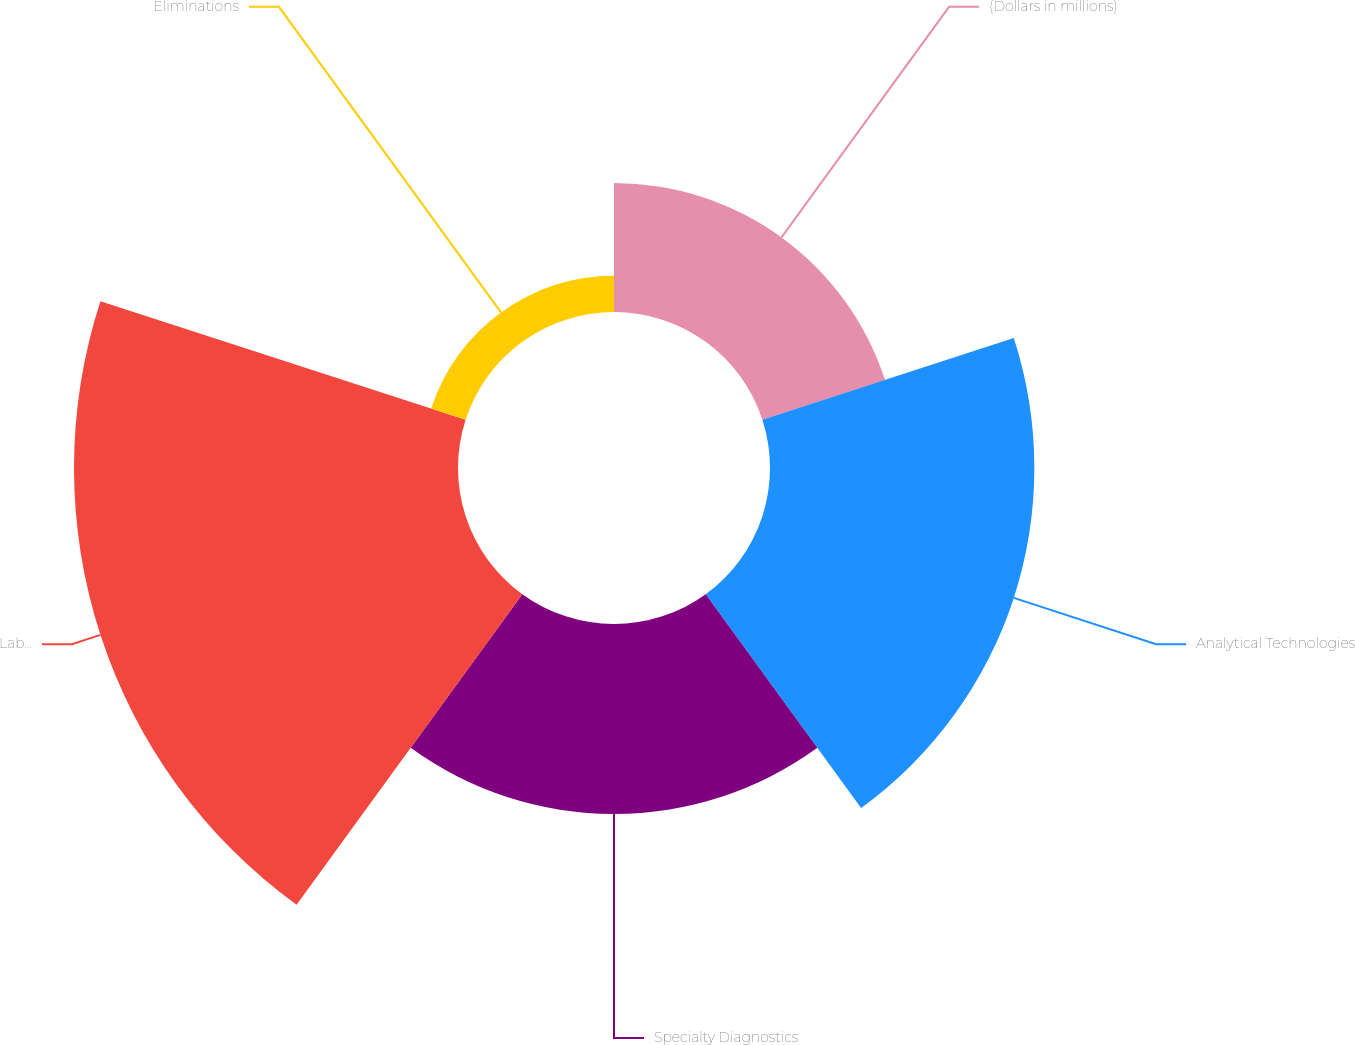Convert chart. <chart><loc_0><loc_0><loc_500><loc_500><pie_chart><fcel>(Dollars in millions)<fcel>Analytical Technologies<fcel>Specialty Diagnostics<fcel>Laboratory Products and<fcel>Eliminations<nl><fcel>12.85%<fcel>26.34%<fcel>18.92%<fcel>38.26%<fcel>3.62%<nl></chart> 